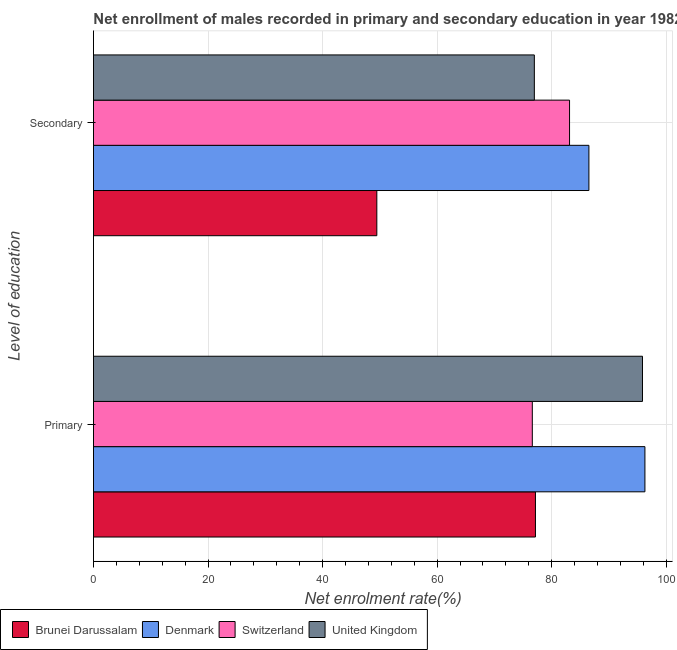Are the number of bars per tick equal to the number of legend labels?
Provide a short and direct response. Yes. Are the number of bars on each tick of the Y-axis equal?
Your answer should be compact. Yes. How many bars are there on the 2nd tick from the bottom?
Provide a short and direct response. 4. What is the label of the 2nd group of bars from the top?
Your answer should be compact. Primary. What is the enrollment rate in primary education in Denmark?
Your answer should be very brief. 96.28. Across all countries, what is the maximum enrollment rate in secondary education?
Offer a very short reply. 86.5. Across all countries, what is the minimum enrollment rate in secondary education?
Keep it short and to the point. 49.47. In which country was the enrollment rate in secondary education maximum?
Ensure brevity in your answer.  Denmark. In which country was the enrollment rate in secondary education minimum?
Your response must be concise. Brunei Darussalam. What is the total enrollment rate in secondary education in the graph?
Offer a terse response. 296.07. What is the difference between the enrollment rate in primary education in Switzerland and that in Brunei Darussalam?
Provide a succinct answer. -0.55. What is the difference between the enrollment rate in primary education in Brunei Darussalam and the enrollment rate in secondary education in Switzerland?
Make the answer very short. -5.95. What is the average enrollment rate in primary education per country?
Provide a short and direct response. 86.48. What is the difference between the enrollment rate in secondary education and enrollment rate in primary education in Denmark?
Your answer should be compact. -9.78. In how many countries, is the enrollment rate in primary education greater than 68 %?
Your answer should be compact. 4. What is the ratio of the enrollment rate in secondary education in Denmark to that in Switzerland?
Offer a very short reply. 1.04. What does the 2nd bar from the top in Primary represents?
Provide a succinct answer. Switzerland. How many bars are there?
Your answer should be compact. 8. How many countries are there in the graph?
Your response must be concise. 4. What is the difference between two consecutive major ticks on the X-axis?
Provide a succinct answer. 20. Does the graph contain any zero values?
Provide a short and direct response. No. What is the title of the graph?
Your answer should be very brief. Net enrollment of males recorded in primary and secondary education in year 1982. Does "Turkey" appear as one of the legend labels in the graph?
Give a very brief answer. No. What is the label or title of the X-axis?
Offer a very short reply. Net enrolment rate(%). What is the label or title of the Y-axis?
Offer a terse response. Level of education. What is the Net enrolment rate(%) of Brunei Darussalam in Primary?
Ensure brevity in your answer.  77.17. What is the Net enrolment rate(%) in Denmark in Primary?
Ensure brevity in your answer.  96.28. What is the Net enrolment rate(%) in Switzerland in Primary?
Your answer should be very brief. 76.62. What is the Net enrolment rate(%) in United Kingdom in Primary?
Offer a terse response. 95.86. What is the Net enrolment rate(%) in Brunei Darussalam in Secondary?
Provide a short and direct response. 49.47. What is the Net enrolment rate(%) in Denmark in Secondary?
Make the answer very short. 86.5. What is the Net enrolment rate(%) of Switzerland in Secondary?
Your response must be concise. 83.12. What is the Net enrolment rate(%) of United Kingdom in Secondary?
Offer a terse response. 76.98. Across all Level of education, what is the maximum Net enrolment rate(%) of Brunei Darussalam?
Provide a short and direct response. 77.17. Across all Level of education, what is the maximum Net enrolment rate(%) in Denmark?
Offer a terse response. 96.28. Across all Level of education, what is the maximum Net enrolment rate(%) in Switzerland?
Keep it short and to the point. 83.12. Across all Level of education, what is the maximum Net enrolment rate(%) in United Kingdom?
Make the answer very short. 95.86. Across all Level of education, what is the minimum Net enrolment rate(%) in Brunei Darussalam?
Your answer should be compact. 49.47. Across all Level of education, what is the minimum Net enrolment rate(%) in Denmark?
Your answer should be compact. 86.5. Across all Level of education, what is the minimum Net enrolment rate(%) of Switzerland?
Ensure brevity in your answer.  76.62. Across all Level of education, what is the minimum Net enrolment rate(%) of United Kingdom?
Your answer should be compact. 76.98. What is the total Net enrolment rate(%) of Brunei Darussalam in the graph?
Make the answer very short. 126.64. What is the total Net enrolment rate(%) in Denmark in the graph?
Your answer should be very brief. 182.78. What is the total Net enrolment rate(%) in Switzerland in the graph?
Make the answer very short. 159.74. What is the total Net enrolment rate(%) in United Kingdom in the graph?
Your answer should be compact. 172.83. What is the difference between the Net enrolment rate(%) of Brunei Darussalam in Primary and that in Secondary?
Give a very brief answer. 27.69. What is the difference between the Net enrolment rate(%) in Denmark in Primary and that in Secondary?
Your response must be concise. 9.78. What is the difference between the Net enrolment rate(%) of Switzerland in Primary and that in Secondary?
Ensure brevity in your answer.  -6.5. What is the difference between the Net enrolment rate(%) of United Kingdom in Primary and that in Secondary?
Keep it short and to the point. 18.88. What is the difference between the Net enrolment rate(%) of Brunei Darussalam in Primary and the Net enrolment rate(%) of Denmark in Secondary?
Your answer should be compact. -9.33. What is the difference between the Net enrolment rate(%) in Brunei Darussalam in Primary and the Net enrolment rate(%) in Switzerland in Secondary?
Provide a short and direct response. -5.95. What is the difference between the Net enrolment rate(%) in Brunei Darussalam in Primary and the Net enrolment rate(%) in United Kingdom in Secondary?
Make the answer very short. 0.19. What is the difference between the Net enrolment rate(%) in Denmark in Primary and the Net enrolment rate(%) in Switzerland in Secondary?
Keep it short and to the point. 13.16. What is the difference between the Net enrolment rate(%) of Denmark in Primary and the Net enrolment rate(%) of United Kingdom in Secondary?
Your answer should be very brief. 19.31. What is the difference between the Net enrolment rate(%) in Switzerland in Primary and the Net enrolment rate(%) in United Kingdom in Secondary?
Keep it short and to the point. -0.35. What is the average Net enrolment rate(%) in Brunei Darussalam per Level of education?
Your answer should be compact. 63.32. What is the average Net enrolment rate(%) of Denmark per Level of education?
Ensure brevity in your answer.  91.39. What is the average Net enrolment rate(%) of Switzerland per Level of education?
Your response must be concise. 79.87. What is the average Net enrolment rate(%) in United Kingdom per Level of education?
Give a very brief answer. 86.42. What is the difference between the Net enrolment rate(%) of Brunei Darussalam and Net enrolment rate(%) of Denmark in Primary?
Your answer should be compact. -19.11. What is the difference between the Net enrolment rate(%) in Brunei Darussalam and Net enrolment rate(%) in Switzerland in Primary?
Make the answer very short. 0.55. What is the difference between the Net enrolment rate(%) of Brunei Darussalam and Net enrolment rate(%) of United Kingdom in Primary?
Give a very brief answer. -18.69. What is the difference between the Net enrolment rate(%) in Denmark and Net enrolment rate(%) in Switzerland in Primary?
Provide a short and direct response. 19.66. What is the difference between the Net enrolment rate(%) of Denmark and Net enrolment rate(%) of United Kingdom in Primary?
Your answer should be very brief. 0.42. What is the difference between the Net enrolment rate(%) of Switzerland and Net enrolment rate(%) of United Kingdom in Primary?
Your response must be concise. -19.24. What is the difference between the Net enrolment rate(%) in Brunei Darussalam and Net enrolment rate(%) in Denmark in Secondary?
Provide a short and direct response. -37.03. What is the difference between the Net enrolment rate(%) in Brunei Darussalam and Net enrolment rate(%) in Switzerland in Secondary?
Provide a succinct answer. -33.65. What is the difference between the Net enrolment rate(%) of Brunei Darussalam and Net enrolment rate(%) of United Kingdom in Secondary?
Give a very brief answer. -27.5. What is the difference between the Net enrolment rate(%) in Denmark and Net enrolment rate(%) in Switzerland in Secondary?
Ensure brevity in your answer.  3.38. What is the difference between the Net enrolment rate(%) of Denmark and Net enrolment rate(%) of United Kingdom in Secondary?
Give a very brief answer. 9.53. What is the difference between the Net enrolment rate(%) of Switzerland and Net enrolment rate(%) of United Kingdom in Secondary?
Your response must be concise. 6.15. What is the ratio of the Net enrolment rate(%) of Brunei Darussalam in Primary to that in Secondary?
Provide a succinct answer. 1.56. What is the ratio of the Net enrolment rate(%) in Denmark in Primary to that in Secondary?
Offer a terse response. 1.11. What is the ratio of the Net enrolment rate(%) of Switzerland in Primary to that in Secondary?
Make the answer very short. 0.92. What is the ratio of the Net enrolment rate(%) in United Kingdom in Primary to that in Secondary?
Your response must be concise. 1.25. What is the difference between the highest and the second highest Net enrolment rate(%) of Brunei Darussalam?
Your answer should be compact. 27.69. What is the difference between the highest and the second highest Net enrolment rate(%) in Denmark?
Offer a terse response. 9.78. What is the difference between the highest and the second highest Net enrolment rate(%) in Switzerland?
Provide a succinct answer. 6.5. What is the difference between the highest and the second highest Net enrolment rate(%) of United Kingdom?
Ensure brevity in your answer.  18.88. What is the difference between the highest and the lowest Net enrolment rate(%) in Brunei Darussalam?
Ensure brevity in your answer.  27.69. What is the difference between the highest and the lowest Net enrolment rate(%) of Denmark?
Give a very brief answer. 9.78. What is the difference between the highest and the lowest Net enrolment rate(%) of Switzerland?
Ensure brevity in your answer.  6.5. What is the difference between the highest and the lowest Net enrolment rate(%) of United Kingdom?
Your response must be concise. 18.88. 